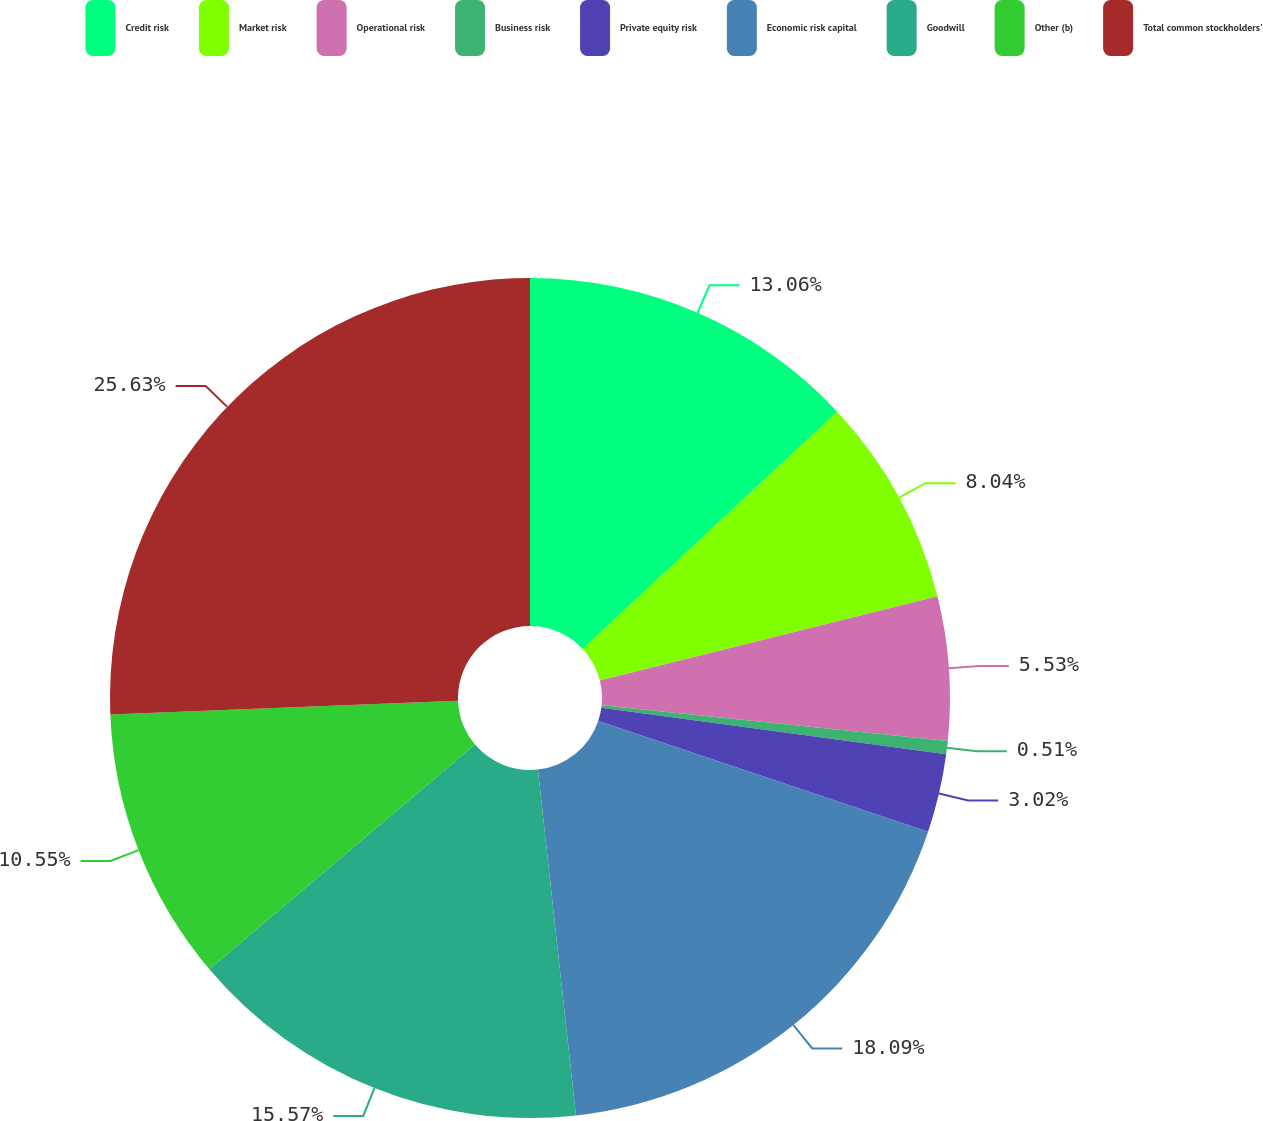Convert chart. <chart><loc_0><loc_0><loc_500><loc_500><pie_chart><fcel>Credit risk<fcel>Market risk<fcel>Operational risk<fcel>Business risk<fcel>Private equity risk<fcel>Economic risk capital<fcel>Goodwill<fcel>Other (b)<fcel>Total common stockholders'<nl><fcel>13.06%<fcel>8.04%<fcel>5.53%<fcel>0.51%<fcel>3.02%<fcel>18.09%<fcel>15.57%<fcel>10.55%<fcel>25.62%<nl></chart> 